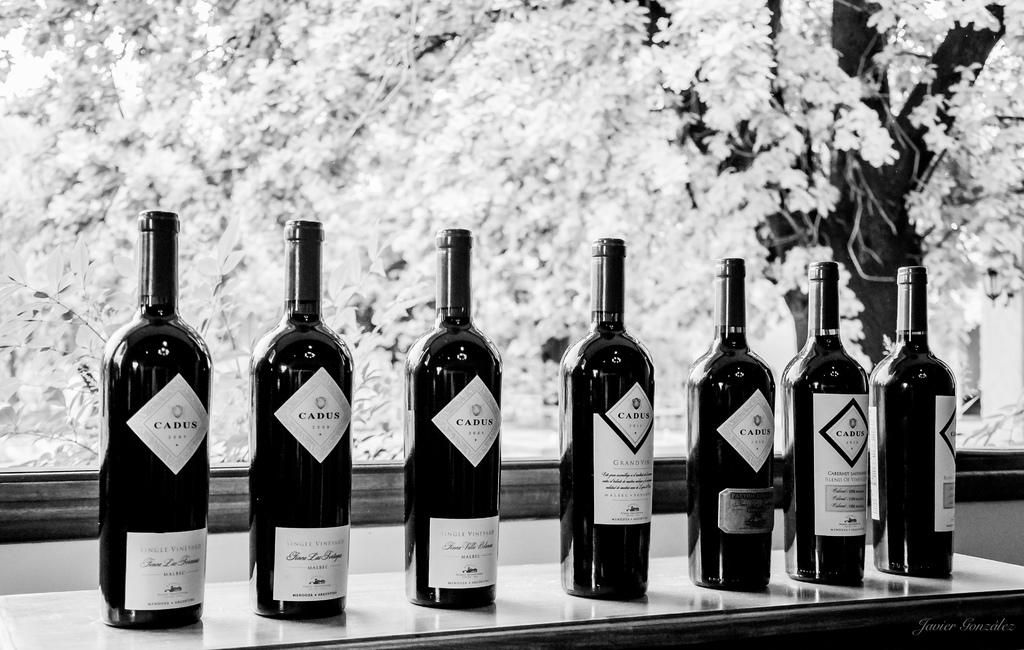What is the brand name of the wines on display?
Your answer should be compact. Cadus. 